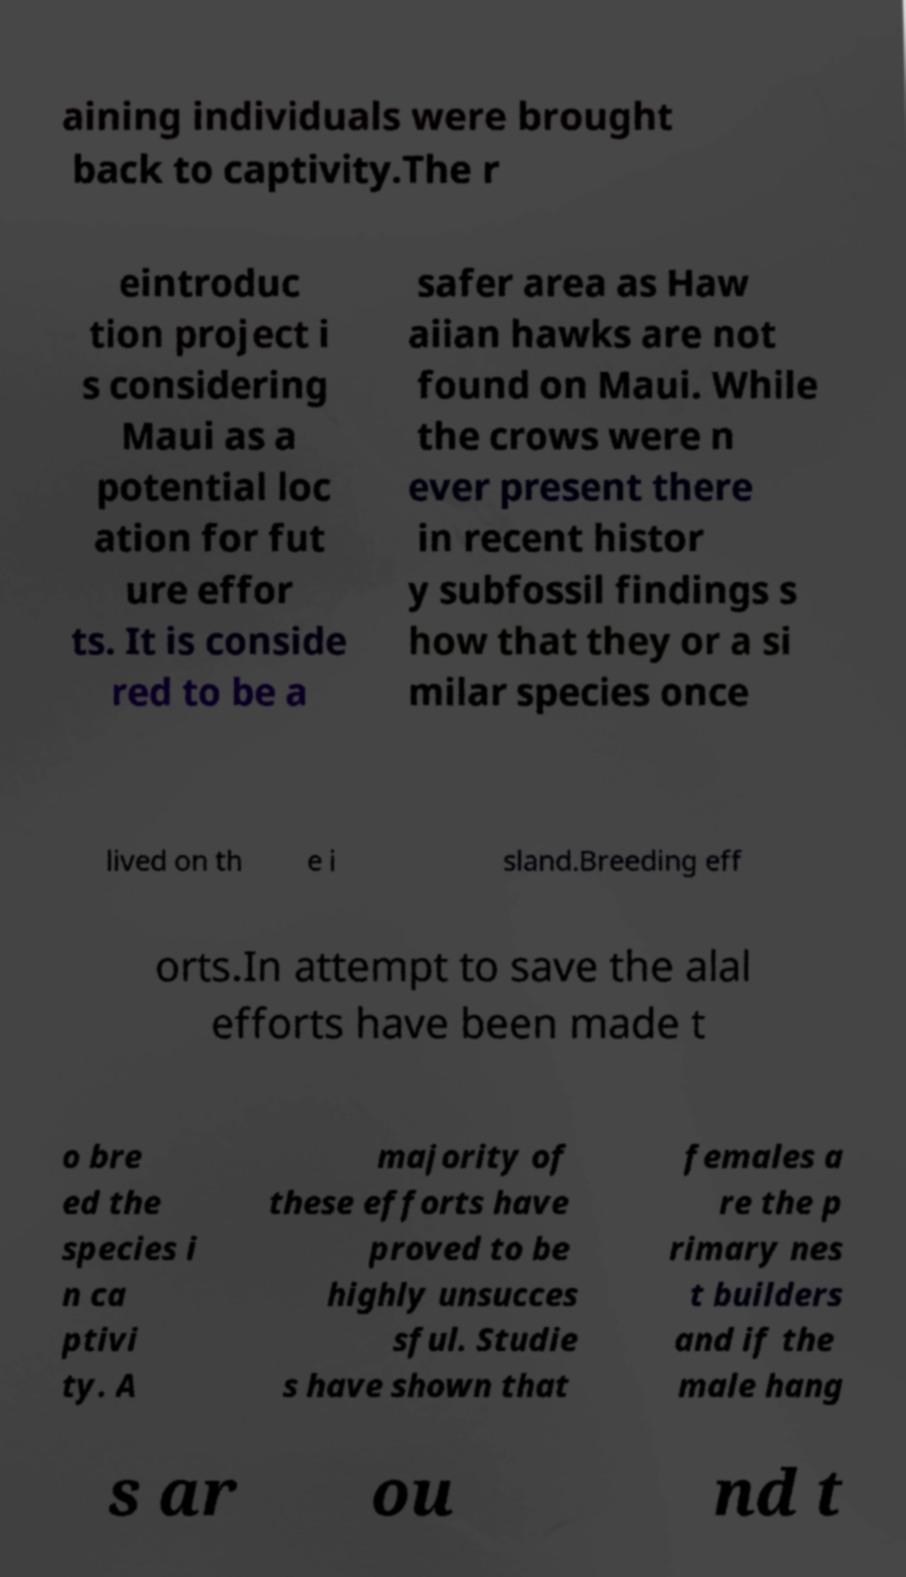I need the written content from this picture converted into text. Can you do that? aining individuals were brought back to captivity.The r eintroduc tion project i s considering Maui as a potential loc ation for fut ure effor ts. It is conside red to be a safer area as Haw aiian hawks are not found on Maui. While the crows were n ever present there in recent histor y subfossil findings s how that they or a si milar species once lived on th e i sland.Breeding eff orts.In attempt to save the alal efforts have been made t o bre ed the species i n ca ptivi ty. A majority of these efforts have proved to be highly unsucces sful. Studie s have shown that females a re the p rimary nes t builders and if the male hang s ar ou nd t 